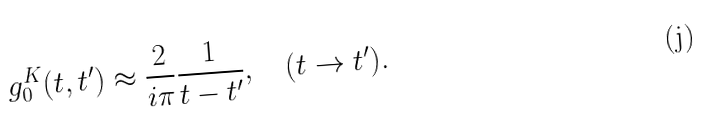<formula> <loc_0><loc_0><loc_500><loc_500>g _ { 0 } ^ { K } ( t , t ^ { \prime } ) \approx \frac { 2 } { i \pi } \frac { 1 } { t - t ^ { \prime } } , \quad ( t \to { t } ^ { \prime } ) .</formula> 